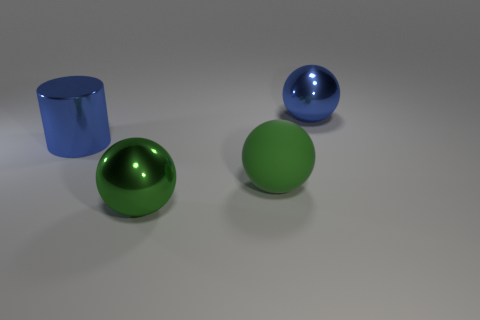Subtract all large metallic spheres. How many spheres are left? 1 Subtract all blue balls. How many balls are left? 2 Subtract 1 spheres. How many spheres are left? 2 Add 2 blue metallic spheres. How many objects exist? 6 Subtract all cylinders. How many objects are left? 3 Subtract all brown blocks. How many red spheres are left? 0 Add 3 yellow blocks. How many yellow blocks exist? 3 Subtract 0 cyan spheres. How many objects are left? 4 Subtract all blue spheres. Subtract all gray cylinders. How many spheres are left? 2 Subtract all big blue cylinders. Subtract all large blue metallic spheres. How many objects are left? 2 